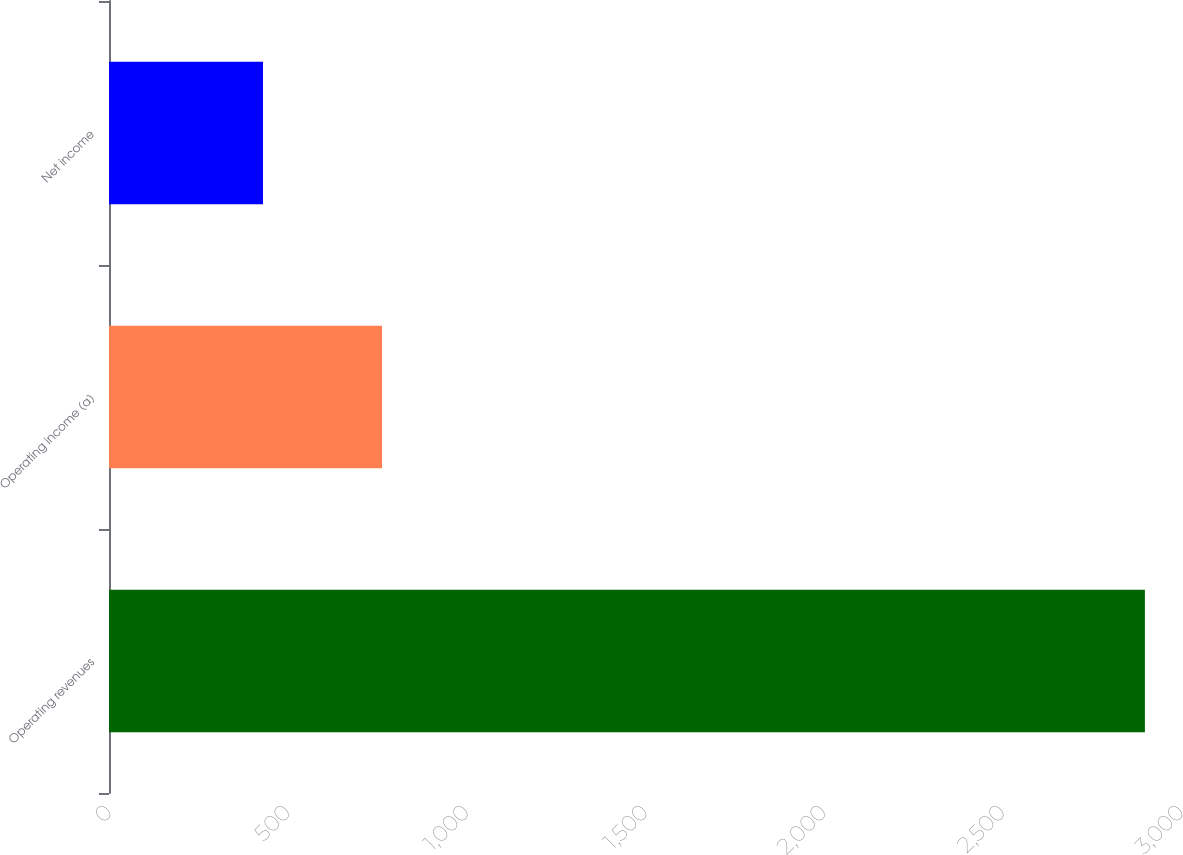Convert chart. <chart><loc_0><loc_0><loc_500><loc_500><bar_chart><fcel>Operating revenues<fcel>Operating income (a)<fcel>Net income<nl><fcel>2899<fcel>764<fcel>431<nl></chart> 